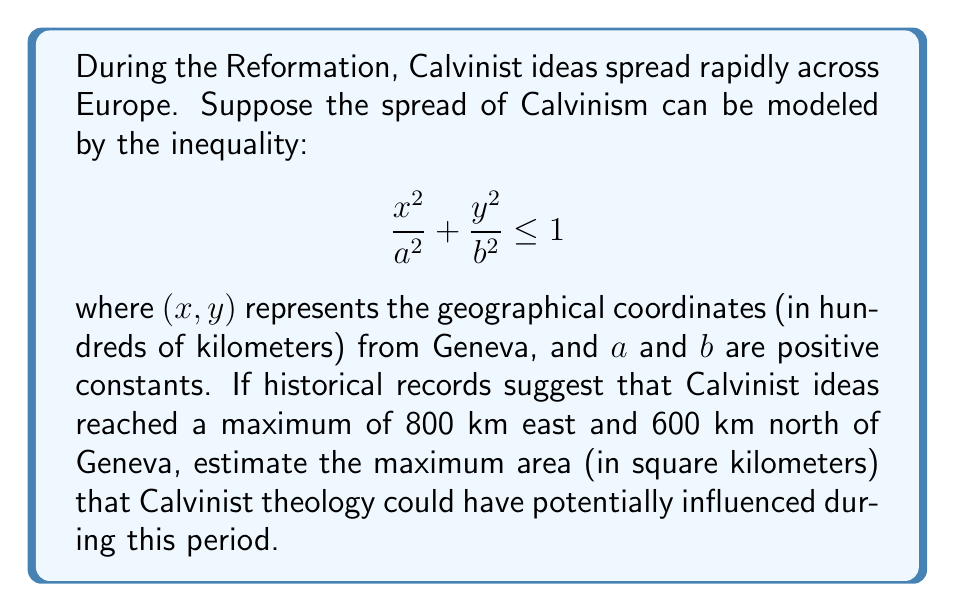Can you solve this math problem? To solve this problem, we need to follow these steps:

1) The inequality represents an ellipse, with Geneva at the center. The maximum reach east (800 km) corresponds to the semi-major axis $a$, and the maximum reach north (600 km) corresponds to the semi-minor axis $b$.

2) Convert the given distances to the scale used in the inequality:
   $a = 800 \div 100 = 8$
   $b = 600 \div 100 = 6$

3) The area of an ellipse is given by the formula:
   $$ A = \pi ab $$

4) Substitute the values:
   $$ A = \pi (8)(6) = 48\pi $$

5) This result is in units of $(100 \text{ km})^2$. To convert to $\text{km}^2$, we need to multiply by $100^2 = 10,000$:
   $$ A = 48\pi \times 10,000 = 480,000\pi \text{ km}^2 $$

6) Calculate the final value:
   $$ A \approx 1,507,964 \text{ km}^2 $$
Answer: The maximum area potentially influenced by Calvinist theology during this period is approximately 1,507,964 square kilometers. 